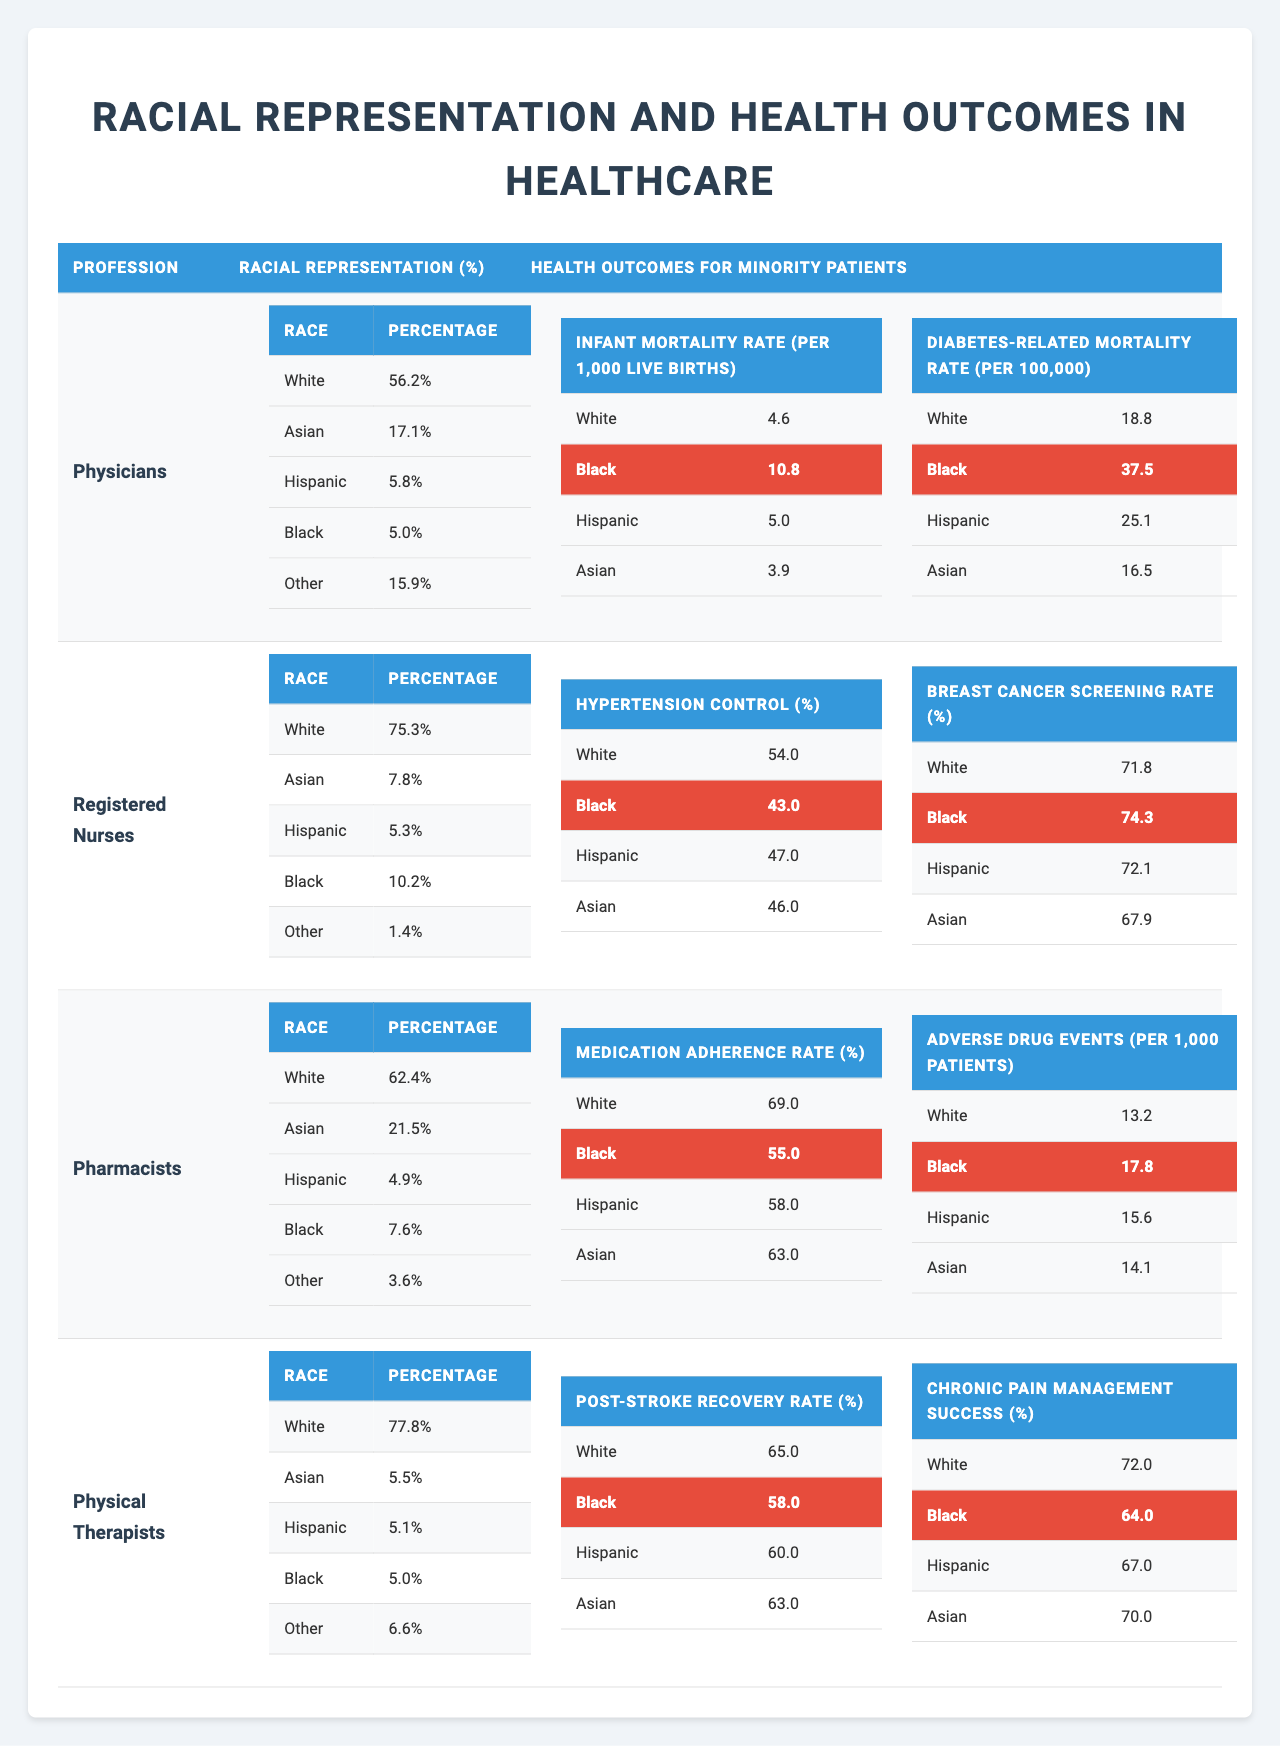What percentage of physicians are Black? According to the table, the racial representation percentage of Black physicians is listed under "Racial Representation (%)" for the "Physicians" profession, which indicates it is 5.0%.
Answer: 5.0% What is the infant mortality rate for Hispanic patients? The infant mortality rate for Hispanic patients is provided in the table under the "Health Outcomes for Minority Patients" section for the "Physicians" profession, which shows it as 5.0 per 1,000 live births.
Answer: 5.0 per 1,000 live births Which medical profession has the highest percentage of White representation? By comparing the "Racial Representation (%)" across all professions, "Registered Nurses" has the highest percentage of White representation at 75.3%.
Answer: Registered Nurses What is the difference in diabetes-related mortality rate between Black and White patients? The diabetes-related mortality rate for Black patients is 37.5 and for White patients it is 18.8. The difference is calculated as 37.5 - 18.8 = 18.7 per 100,000.
Answer: 18.7 per 100,000 For the profession of Pharmacists, what is the average medication adherence rate across different racial groups? The medication adherence rates for different racial groups are 69.0 (White), 55.0 (Black), 58.0 (Hispanic), and 63.0 (Asian). To find the average, sum these values: 69.0 + 55.0 + 58.0 + 63.0 = 245.0. Divide by the number of groups: 245.0 / 4 = 61.25.
Answer: 61.25 Are there any professions where the hypertension control rate for Black patients exceeds 50%? Checking the hypertension control rates, we see that the rate for Black patients in "Registered Nurses" is 43.0%, below 50%, and in "Physicians," it is not applicable, thus there are no professions listed where Black patients exceed 50%.
Answer: No What is the highest adverse drug events rate recorded among minority groups in the list? The rates are 17.8 (Black), 15.6 (Hispanic), 14.1 (Asian), and 13.2 (White). The highest is 17.8 for Black patients, which is identified in the "Health Outcomes for Minority Patients" for "Pharmacists."
Answer: 17.8 In which medical profession do Black patients have the highest post-stroke recovery rate? The "Post-Stroke Recovery Rate" shows Black patients have a recovery rate of 58.0% in "Physical Therapists," which is higher compared to other professions listed in the table.
Answer: Physical Therapists What is the percentage of Asian representation among Physical Therapists? The racial representation of Asians among Physical Therapists is directly indicated in the table as 5.5%.
Answer: 5.5% What can you infer about the health outcomes for minority patients when the racial representation of physicians is low? The data shows that with low representation (5.0% for Black), health outcomes suboptimal (e.g., a higher infant mortality rate of 10.8). This suggests a possible correlation between low representation and poor health outcomes.
Answer: Infer a negative correlation 